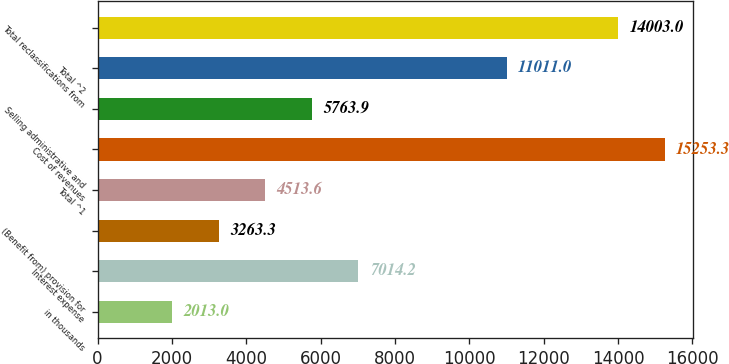Convert chart to OTSL. <chart><loc_0><loc_0><loc_500><loc_500><bar_chart><fcel>in thousands<fcel>Interest expense<fcel>(Benefit from) provision for<fcel>Total ^1<fcel>Cost of revenues<fcel>Selling administrative and<fcel>Total ^2<fcel>Total reclassifications from<nl><fcel>2013<fcel>7014.2<fcel>3263.3<fcel>4513.6<fcel>15253.3<fcel>5763.9<fcel>11011<fcel>14003<nl></chart> 